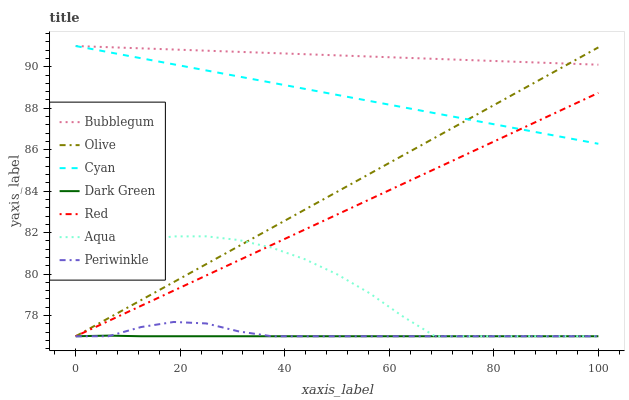Does Dark Green have the minimum area under the curve?
Answer yes or no. Yes. Does Bubblegum have the maximum area under the curve?
Answer yes or no. Yes. Does Periwinkle have the minimum area under the curve?
Answer yes or no. No. Does Periwinkle have the maximum area under the curve?
Answer yes or no. No. Is Olive the smoothest?
Answer yes or no. Yes. Is Aqua the roughest?
Answer yes or no. Yes. Is Bubblegum the smoothest?
Answer yes or no. No. Is Bubblegum the roughest?
Answer yes or no. No. Does Aqua have the lowest value?
Answer yes or no. Yes. Does Bubblegum have the lowest value?
Answer yes or no. No. Does Cyan have the highest value?
Answer yes or no. Yes. Does Periwinkle have the highest value?
Answer yes or no. No. Is Dark Green less than Bubblegum?
Answer yes or no. Yes. Is Cyan greater than Aqua?
Answer yes or no. Yes. Does Dark Green intersect Olive?
Answer yes or no. Yes. Is Dark Green less than Olive?
Answer yes or no. No. Is Dark Green greater than Olive?
Answer yes or no. No. Does Dark Green intersect Bubblegum?
Answer yes or no. No. 